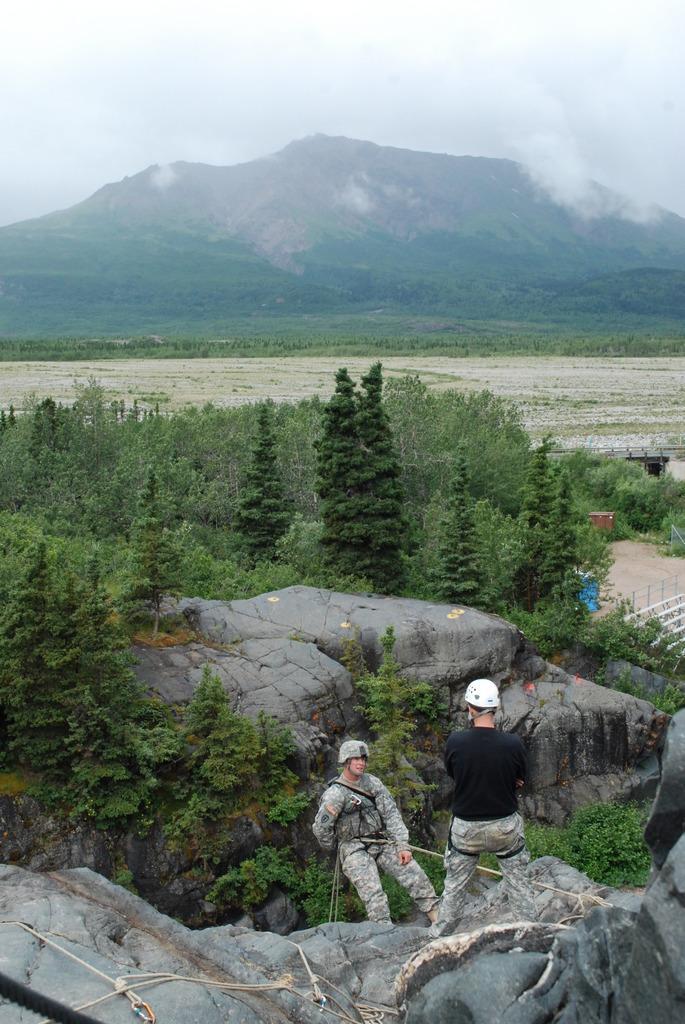In one or two sentences, can you explain what this image depicts? This is an outside view. At the bottom there are two persons wearing helmets on their heads and standing on the rocks. In the middle of the image there are many trees. In the background there is a mountain. At the top of the image I can see the sky. 